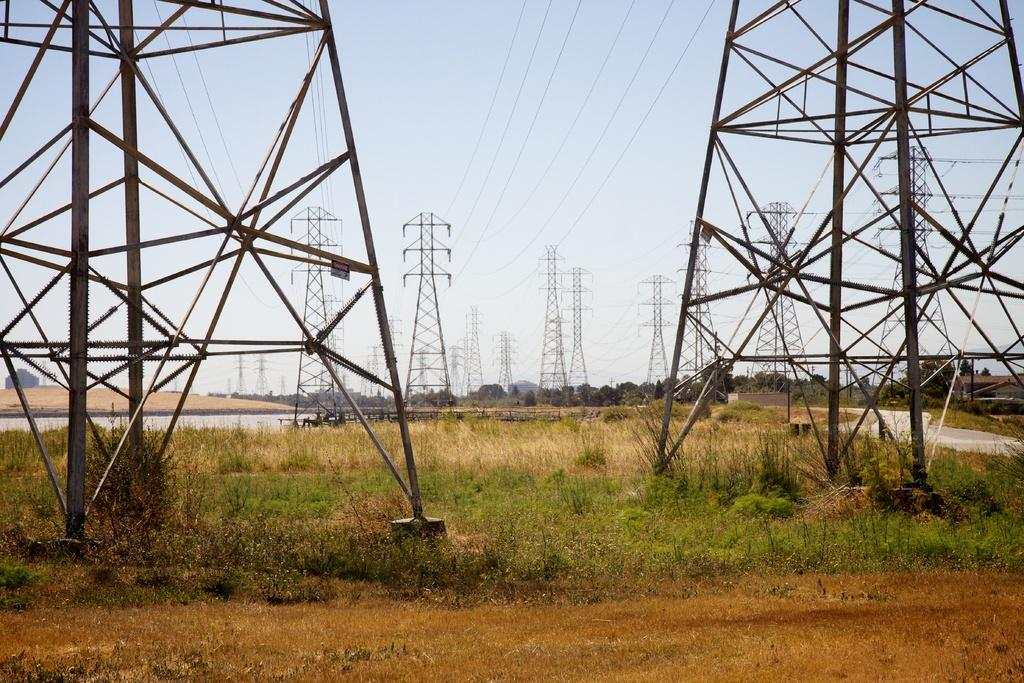What structures are present in the image? There are mobile towers in the image. What else can be seen in the image besides the mobile towers? There are wires in the image. What is at the bottom of the image? There is grass at the bottom of the image. What can be seen in the background of the image? There are trees and the sky visible in the background of the image. What type of guitar is being played by the person in the image? There is no person or guitar present in the image; it features mobile towers, wires, grass, trees, and the sky. 